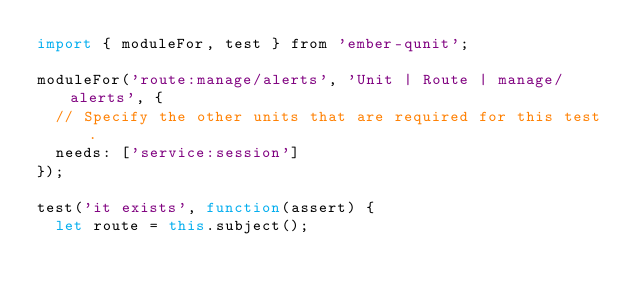<code> <loc_0><loc_0><loc_500><loc_500><_JavaScript_>import { moduleFor, test } from 'ember-qunit';

moduleFor('route:manage/alerts', 'Unit | Route | manage/alerts', {
  // Specify the other units that are required for this test.
  needs: ['service:session']
});

test('it exists', function(assert) {
  let route = this.subject();</code> 